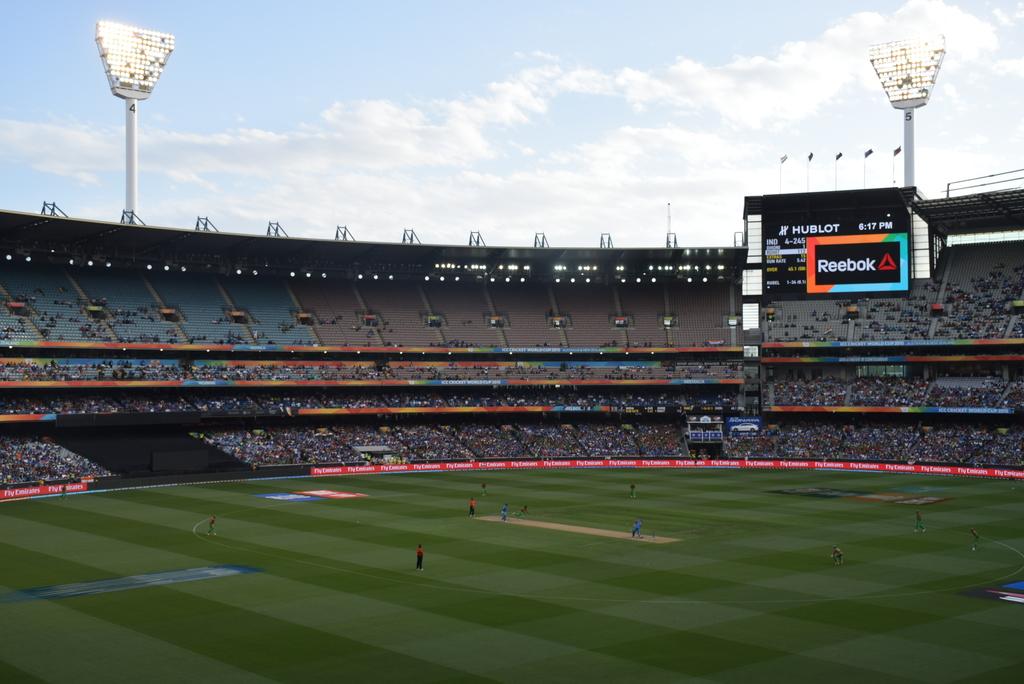What logo is on the score board?
Provide a short and direct response. Reebok. What athletic company is written next to the red triangle on the big sign?
Provide a succinct answer. Reebok. 